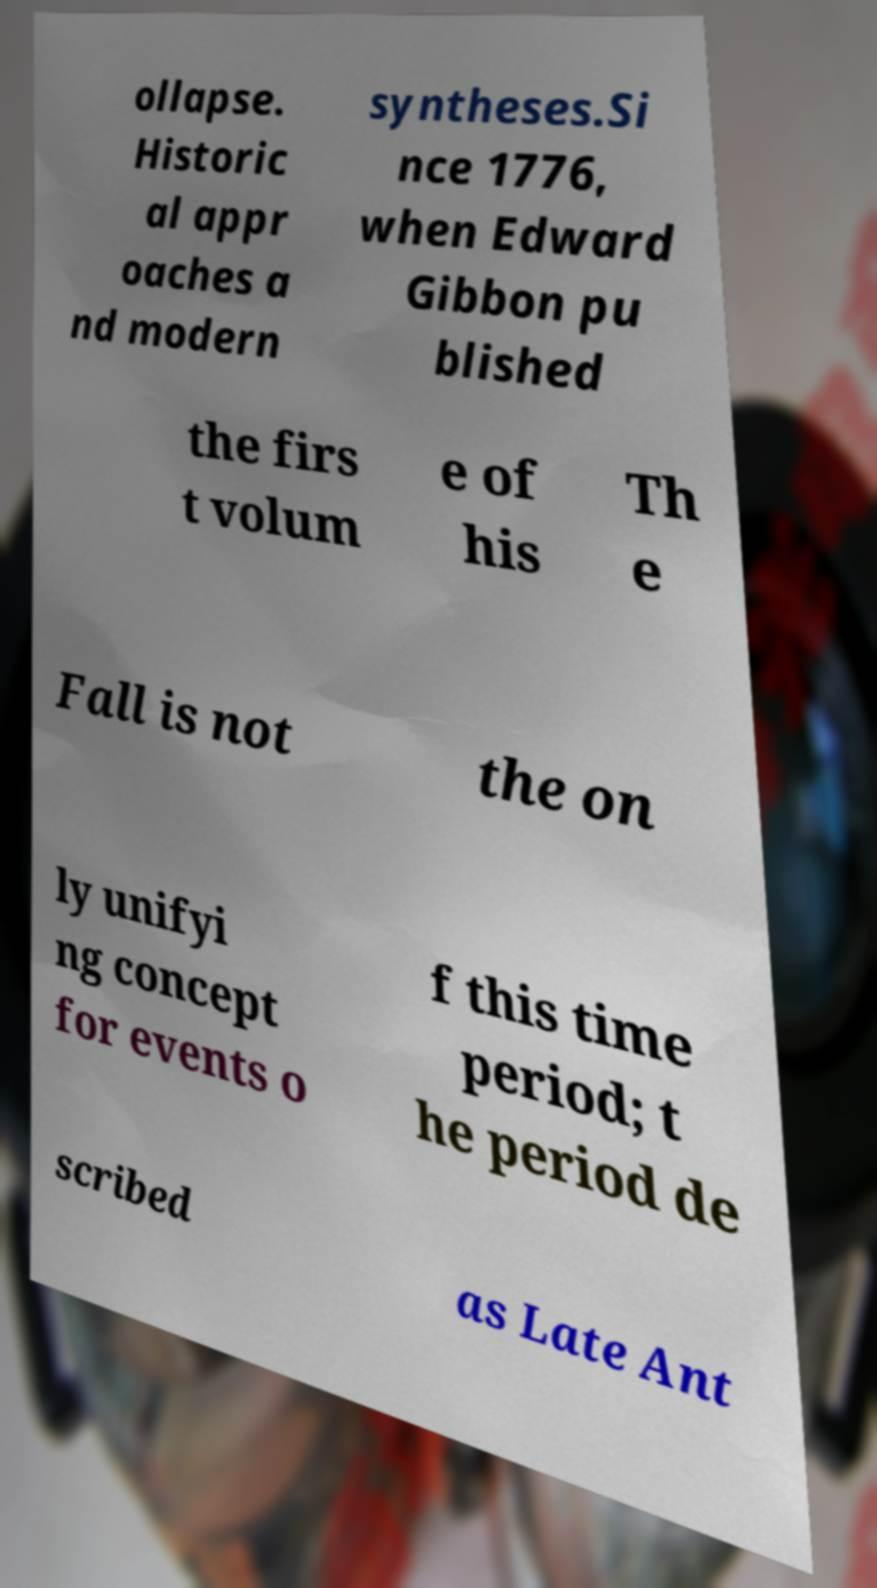Can you accurately transcribe the text from the provided image for me? ollapse. Historic al appr oaches a nd modern syntheses.Si nce 1776, when Edward Gibbon pu blished the firs t volum e of his Th e Fall is not the on ly unifyi ng concept for events o f this time period; t he period de scribed as Late Ant 